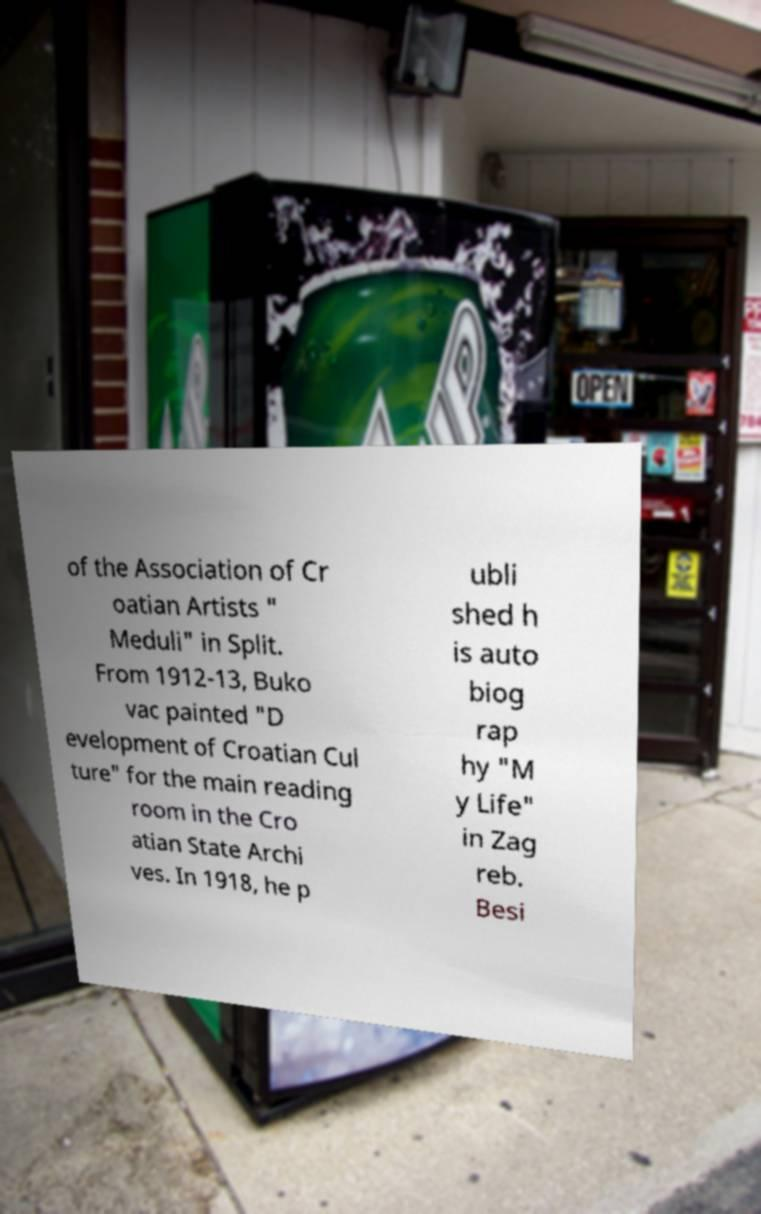For documentation purposes, I need the text within this image transcribed. Could you provide that? of the Association of Cr oatian Artists " Meduli" in Split. From 1912-13, Buko vac painted "D evelopment of Croatian Cul ture" for the main reading room in the Cro atian State Archi ves. In 1918, he p ubli shed h is auto biog rap hy "M y Life" in Zag reb. Besi 